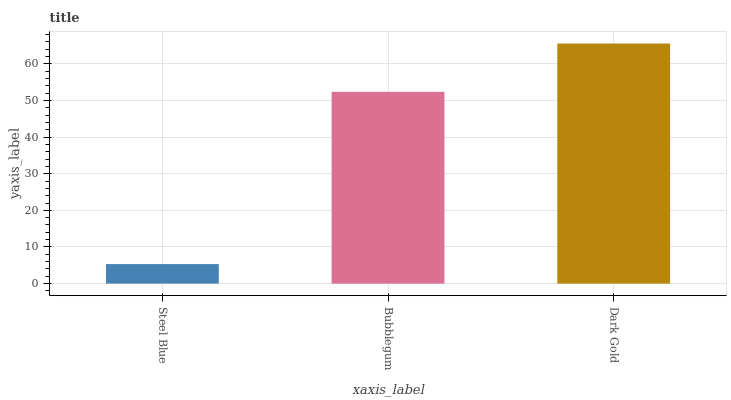Is Steel Blue the minimum?
Answer yes or no. Yes. Is Dark Gold the maximum?
Answer yes or no. Yes. Is Bubblegum the minimum?
Answer yes or no. No. Is Bubblegum the maximum?
Answer yes or no. No. Is Bubblegum greater than Steel Blue?
Answer yes or no. Yes. Is Steel Blue less than Bubblegum?
Answer yes or no. Yes. Is Steel Blue greater than Bubblegum?
Answer yes or no. No. Is Bubblegum less than Steel Blue?
Answer yes or no. No. Is Bubblegum the high median?
Answer yes or no. Yes. Is Bubblegum the low median?
Answer yes or no. Yes. Is Dark Gold the high median?
Answer yes or no. No. Is Steel Blue the low median?
Answer yes or no. No. 